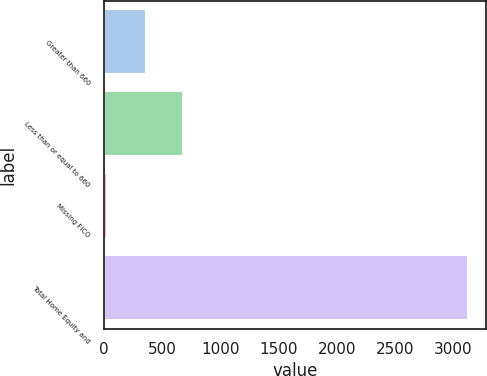Convert chart to OTSL. <chart><loc_0><loc_0><loc_500><loc_500><bar_chart><fcel>Greater than 660<fcel>Less than or equal to 660<fcel>Missing FICO<fcel>Total Home Equity and<nl><fcel>361<fcel>681<fcel>22<fcel>3128<nl></chart> 